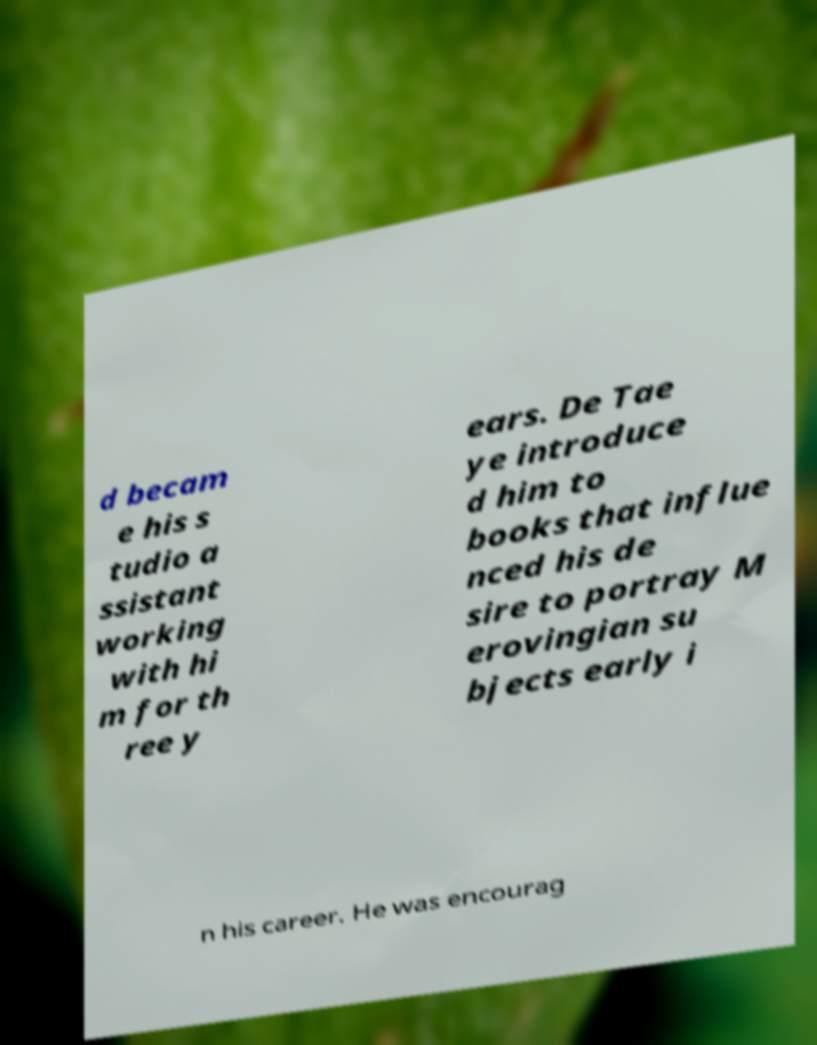What messages or text are displayed in this image? I need them in a readable, typed format. d becam e his s tudio a ssistant working with hi m for th ree y ears. De Tae ye introduce d him to books that influe nced his de sire to portray M erovingian su bjects early i n his career. He was encourag 